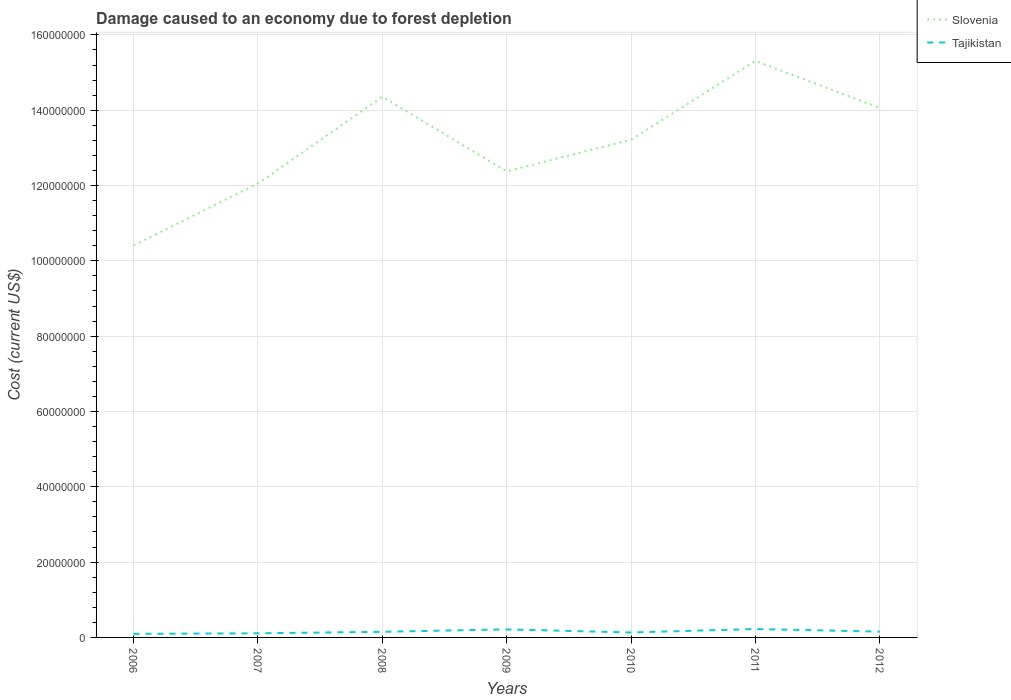How many different coloured lines are there?
Offer a terse response. 2. Does the line corresponding to Slovenia intersect with the line corresponding to Tajikistan?
Keep it short and to the point. No. Is the number of lines equal to the number of legend labels?
Your response must be concise. Yes. Across all years, what is the maximum cost of damage caused due to forest depletion in Slovenia?
Make the answer very short. 1.04e+08. In which year was the cost of damage caused due to forest depletion in Tajikistan maximum?
Keep it short and to the point. 2006. What is the total cost of damage caused due to forest depletion in Slovenia in the graph?
Give a very brief answer. -3.65e+07. What is the difference between the highest and the second highest cost of damage caused due to forest depletion in Tajikistan?
Your response must be concise. 1.28e+06. What is the difference between the highest and the lowest cost of damage caused due to forest depletion in Slovenia?
Offer a terse response. 4. How many years are there in the graph?
Offer a terse response. 7. What is the difference between two consecutive major ticks on the Y-axis?
Ensure brevity in your answer.  2.00e+07. Does the graph contain any zero values?
Offer a very short reply. No. Where does the legend appear in the graph?
Your response must be concise. Top right. How many legend labels are there?
Offer a very short reply. 2. What is the title of the graph?
Your answer should be compact. Damage caused to an economy due to forest depletion. What is the label or title of the Y-axis?
Your response must be concise. Cost (current US$). What is the Cost (current US$) of Slovenia in 2006?
Provide a short and direct response. 1.04e+08. What is the Cost (current US$) in Tajikistan in 2006?
Ensure brevity in your answer.  9.51e+05. What is the Cost (current US$) in Slovenia in 2007?
Offer a very short reply. 1.21e+08. What is the Cost (current US$) in Tajikistan in 2007?
Give a very brief answer. 1.10e+06. What is the Cost (current US$) in Slovenia in 2008?
Provide a succinct answer. 1.44e+08. What is the Cost (current US$) of Tajikistan in 2008?
Give a very brief answer. 1.50e+06. What is the Cost (current US$) in Slovenia in 2009?
Keep it short and to the point. 1.24e+08. What is the Cost (current US$) of Tajikistan in 2009?
Your answer should be very brief. 2.13e+06. What is the Cost (current US$) of Slovenia in 2010?
Ensure brevity in your answer.  1.32e+08. What is the Cost (current US$) of Tajikistan in 2010?
Your answer should be very brief. 1.31e+06. What is the Cost (current US$) of Slovenia in 2011?
Your response must be concise. 1.53e+08. What is the Cost (current US$) in Tajikistan in 2011?
Offer a very short reply. 2.23e+06. What is the Cost (current US$) in Slovenia in 2012?
Your response must be concise. 1.41e+08. What is the Cost (current US$) of Tajikistan in 2012?
Offer a terse response. 1.55e+06. Across all years, what is the maximum Cost (current US$) of Slovenia?
Ensure brevity in your answer.  1.53e+08. Across all years, what is the maximum Cost (current US$) of Tajikistan?
Ensure brevity in your answer.  2.23e+06. Across all years, what is the minimum Cost (current US$) of Slovenia?
Your answer should be compact. 1.04e+08. Across all years, what is the minimum Cost (current US$) in Tajikistan?
Your response must be concise. 9.51e+05. What is the total Cost (current US$) of Slovenia in the graph?
Give a very brief answer. 9.18e+08. What is the total Cost (current US$) of Tajikistan in the graph?
Provide a succinct answer. 1.08e+07. What is the difference between the Cost (current US$) in Slovenia in 2006 and that in 2007?
Ensure brevity in your answer.  -1.64e+07. What is the difference between the Cost (current US$) in Tajikistan in 2006 and that in 2007?
Make the answer very short. -1.45e+05. What is the difference between the Cost (current US$) of Slovenia in 2006 and that in 2008?
Ensure brevity in your answer.  -3.95e+07. What is the difference between the Cost (current US$) in Tajikistan in 2006 and that in 2008?
Your answer should be compact. -5.46e+05. What is the difference between the Cost (current US$) in Slovenia in 2006 and that in 2009?
Provide a short and direct response. -1.97e+07. What is the difference between the Cost (current US$) of Tajikistan in 2006 and that in 2009?
Give a very brief answer. -1.18e+06. What is the difference between the Cost (current US$) in Slovenia in 2006 and that in 2010?
Your answer should be very brief. -2.81e+07. What is the difference between the Cost (current US$) in Tajikistan in 2006 and that in 2010?
Keep it short and to the point. -3.62e+05. What is the difference between the Cost (current US$) in Slovenia in 2006 and that in 2011?
Offer a terse response. -4.90e+07. What is the difference between the Cost (current US$) of Tajikistan in 2006 and that in 2011?
Provide a succinct answer. -1.28e+06. What is the difference between the Cost (current US$) of Slovenia in 2006 and that in 2012?
Give a very brief answer. -3.65e+07. What is the difference between the Cost (current US$) in Tajikistan in 2006 and that in 2012?
Provide a short and direct response. -5.98e+05. What is the difference between the Cost (current US$) of Slovenia in 2007 and that in 2008?
Your response must be concise. -2.31e+07. What is the difference between the Cost (current US$) in Tajikistan in 2007 and that in 2008?
Keep it short and to the point. -4.01e+05. What is the difference between the Cost (current US$) in Slovenia in 2007 and that in 2009?
Offer a very short reply. -3.25e+06. What is the difference between the Cost (current US$) of Tajikistan in 2007 and that in 2009?
Offer a very short reply. -1.04e+06. What is the difference between the Cost (current US$) in Slovenia in 2007 and that in 2010?
Ensure brevity in your answer.  -1.17e+07. What is the difference between the Cost (current US$) in Tajikistan in 2007 and that in 2010?
Your answer should be very brief. -2.16e+05. What is the difference between the Cost (current US$) of Slovenia in 2007 and that in 2011?
Offer a terse response. -3.26e+07. What is the difference between the Cost (current US$) in Tajikistan in 2007 and that in 2011?
Provide a succinct answer. -1.13e+06. What is the difference between the Cost (current US$) in Slovenia in 2007 and that in 2012?
Provide a succinct answer. -2.01e+07. What is the difference between the Cost (current US$) of Tajikistan in 2007 and that in 2012?
Give a very brief answer. -4.52e+05. What is the difference between the Cost (current US$) in Slovenia in 2008 and that in 2009?
Provide a succinct answer. 1.98e+07. What is the difference between the Cost (current US$) in Tajikistan in 2008 and that in 2009?
Make the answer very short. -6.36e+05. What is the difference between the Cost (current US$) of Slovenia in 2008 and that in 2010?
Provide a short and direct response. 1.14e+07. What is the difference between the Cost (current US$) in Tajikistan in 2008 and that in 2010?
Offer a very short reply. 1.84e+05. What is the difference between the Cost (current US$) of Slovenia in 2008 and that in 2011?
Provide a succinct answer. -9.53e+06. What is the difference between the Cost (current US$) of Tajikistan in 2008 and that in 2011?
Your response must be concise. -7.31e+05. What is the difference between the Cost (current US$) of Slovenia in 2008 and that in 2012?
Offer a terse response. 2.99e+06. What is the difference between the Cost (current US$) in Tajikistan in 2008 and that in 2012?
Ensure brevity in your answer.  -5.17e+04. What is the difference between the Cost (current US$) of Slovenia in 2009 and that in 2010?
Your answer should be compact. -8.43e+06. What is the difference between the Cost (current US$) in Tajikistan in 2009 and that in 2010?
Offer a terse response. 8.21e+05. What is the difference between the Cost (current US$) in Slovenia in 2009 and that in 2011?
Provide a short and direct response. -2.93e+07. What is the difference between the Cost (current US$) in Tajikistan in 2009 and that in 2011?
Ensure brevity in your answer.  -9.45e+04. What is the difference between the Cost (current US$) of Slovenia in 2009 and that in 2012?
Your answer should be very brief. -1.68e+07. What is the difference between the Cost (current US$) of Tajikistan in 2009 and that in 2012?
Your answer should be compact. 5.85e+05. What is the difference between the Cost (current US$) in Slovenia in 2010 and that in 2011?
Ensure brevity in your answer.  -2.09e+07. What is the difference between the Cost (current US$) of Tajikistan in 2010 and that in 2011?
Ensure brevity in your answer.  -9.15e+05. What is the difference between the Cost (current US$) of Slovenia in 2010 and that in 2012?
Keep it short and to the point. -8.40e+06. What is the difference between the Cost (current US$) of Tajikistan in 2010 and that in 2012?
Provide a succinct answer. -2.36e+05. What is the difference between the Cost (current US$) in Slovenia in 2011 and that in 2012?
Your answer should be very brief. 1.25e+07. What is the difference between the Cost (current US$) in Tajikistan in 2011 and that in 2012?
Your answer should be compact. 6.79e+05. What is the difference between the Cost (current US$) in Slovenia in 2006 and the Cost (current US$) in Tajikistan in 2007?
Give a very brief answer. 1.03e+08. What is the difference between the Cost (current US$) in Slovenia in 2006 and the Cost (current US$) in Tajikistan in 2008?
Ensure brevity in your answer.  1.03e+08. What is the difference between the Cost (current US$) in Slovenia in 2006 and the Cost (current US$) in Tajikistan in 2009?
Your answer should be compact. 1.02e+08. What is the difference between the Cost (current US$) of Slovenia in 2006 and the Cost (current US$) of Tajikistan in 2010?
Make the answer very short. 1.03e+08. What is the difference between the Cost (current US$) of Slovenia in 2006 and the Cost (current US$) of Tajikistan in 2011?
Make the answer very short. 1.02e+08. What is the difference between the Cost (current US$) in Slovenia in 2006 and the Cost (current US$) in Tajikistan in 2012?
Keep it short and to the point. 1.03e+08. What is the difference between the Cost (current US$) of Slovenia in 2007 and the Cost (current US$) of Tajikistan in 2008?
Offer a terse response. 1.19e+08. What is the difference between the Cost (current US$) of Slovenia in 2007 and the Cost (current US$) of Tajikistan in 2009?
Keep it short and to the point. 1.18e+08. What is the difference between the Cost (current US$) in Slovenia in 2007 and the Cost (current US$) in Tajikistan in 2010?
Provide a short and direct response. 1.19e+08. What is the difference between the Cost (current US$) in Slovenia in 2007 and the Cost (current US$) in Tajikistan in 2011?
Make the answer very short. 1.18e+08. What is the difference between the Cost (current US$) in Slovenia in 2007 and the Cost (current US$) in Tajikistan in 2012?
Give a very brief answer. 1.19e+08. What is the difference between the Cost (current US$) of Slovenia in 2008 and the Cost (current US$) of Tajikistan in 2009?
Your answer should be compact. 1.41e+08. What is the difference between the Cost (current US$) of Slovenia in 2008 and the Cost (current US$) of Tajikistan in 2010?
Provide a short and direct response. 1.42e+08. What is the difference between the Cost (current US$) of Slovenia in 2008 and the Cost (current US$) of Tajikistan in 2011?
Your response must be concise. 1.41e+08. What is the difference between the Cost (current US$) of Slovenia in 2008 and the Cost (current US$) of Tajikistan in 2012?
Keep it short and to the point. 1.42e+08. What is the difference between the Cost (current US$) in Slovenia in 2009 and the Cost (current US$) in Tajikistan in 2010?
Give a very brief answer. 1.22e+08. What is the difference between the Cost (current US$) in Slovenia in 2009 and the Cost (current US$) in Tajikistan in 2011?
Ensure brevity in your answer.  1.22e+08. What is the difference between the Cost (current US$) of Slovenia in 2009 and the Cost (current US$) of Tajikistan in 2012?
Provide a short and direct response. 1.22e+08. What is the difference between the Cost (current US$) of Slovenia in 2010 and the Cost (current US$) of Tajikistan in 2011?
Your answer should be very brief. 1.30e+08. What is the difference between the Cost (current US$) in Slovenia in 2010 and the Cost (current US$) in Tajikistan in 2012?
Ensure brevity in your answer.  1.31e+08. What is the difference between the Cost (current US$) in Slovenia in 2011 and the Cost (current US$) in Tajikistan in 2012?
Your response must be concise. 1.52e+08. What is the average Cost (current US$) of Slovenia per year?
Your answer should be very brief. 1.31e+08. What is the average Cost (current US$) of Tajikistan per year?
Offer a terse response. 1.54e+06. In the year 2006, what is the difference between the Cost (current US$) of Slovenia and Cost (current US$) of Tajikistan?
Offer a very short reply. 1.03e+08. In the year 2007, what is the difference between the Cost (current US$) in Slovenia and Cost (current US$) in Tajikistan?
Provide a succinct answer. 1.19e+08. In the year 2008, what is the difference between the Cost (current US$) in Slovenia and Cost (current US$) in Tajikistan?
Your answer should be compact. 1.42e+08. In the year 2009, what is the difference between the Cost (current US$) in Slovenia and Cost (current US$) in Tajikistan?
Your answer should be very brief. 1.22e+08. In the year 2010, what is the difference between the Cost (current US$) of Slovenia and Cost (current US$) of Tajikistan?
Your answer should be very brief. 1.31e+08. In the year 2011, what is the difference between the Cost (current US$) of Slovenia and Cost (current US$) of Tajikistan?
Ensure brevity in your answer.  1.51e+08. In the year 2012, what is the difference between the Cost (current US$) of Slovenia and Cost (current US$) of Tajikistan?
Offer a very short reply. 1.39e+08. What is the ratio of the Cost (current US$) of Slovenia in 2006 to that in 2007?
Offer a terse response. 0.86. What is the ratio of the Cost (current US$) of Tajikistan in 2006 to that in 2007?
Your answer should be compact. 0.87. What is the ratio of the Cost (current US$) in Slovenia in 2006 to that in 2008?
Ensure brevity in your answer.  0.72. What is the ratio of the Cost (current US$) of Tajikistan in 2006 to that in 2008?
Offer a very short reply. 0.64. What is the ratio of the Cost (current US$) in Slovenia in 2006 to that in 2009?
Provide a short and direct response. 0.84. What is the ratio of the Cost (current US$) of Tajikistan in 2006 to that in 2009?
Offer a terse response. 0.45. What is the ratio of the Cost (current US$) in Slovenia in 2006 to that in 2010?
Offer a very short reply. 0.79. What is the ratio of the Cost (current US$) of Tajikistan in 2006 to that in 2010?
Make the answer very short. 0.72. What is the ratio of the Cost (current US$) of Slovenia in 2006 to that in 2011?
Keep it short and to the point. 0.68. What is the ratio of the Cost (current US$) in Tajikistan in 2006 to that in 2011?
Give a very brief answer. 0.43. What is the ratio of the Cost (current US$) in Slovenia in 2006 to that in 2012?
Your answer should be very brief. 0.74. What is the ratio of the Cost (current US$) of Tajikistan in 2006 to that in 2012?
Give a very brief answer. 0.61. What is the ratio of the Cost (current US$) in Slovenia in 2007 to that in 2008?
Provide a succinct answer. 0.84. What is the ratio of the Cost (current US$) of Tajikistan in 2007 to that in 2008?
Offer a terse response. 0.73. What is the ratio of the Cost (current US$) of Slovenia in 2007 to that in 2009?
Provide a short and direct response. 0.97. What is the ratio of the Cost (current US$) of Tajikistan in 2007 to that in 2009?
Your answer should be very brief. 0.51. What is the ratio of the Cost (current US$) of Slovenia in 2007 to that in 2010?
Ensure brevity in your answer.  0.91. What is the ratio of the Cost (current US$) of Tajikistan in 2007 to that in 2010?
Ensure brevity in your answer.  0.84. What is the ratio of the Cost (current US$) of Slovenia in 2007 to that in 2011?
Offer a very short reply. 0.79. What is the ratio of the Cost (current US$) of Tajikistan in 2007 to that in 2011?
Offer a very short reply. 0.49. What is the ratio of the Cost (current US$) in Slovenia in 2007 to that in 2012?
Your response must be concise. 0.86. What is the ratio of the Cost (current US$) of Tajikistan in 2007 to that in 2012?
Ensure brevity in your answer.  0.71. What is the ratio of the Cost (current US$) of Slovenia in 2008 to that in 2009?
Keep it short and to the point. 1.16. What is the ratio of the Cost (current US$) of Tajikistan in 2008 to that in 2009?
Keep it short and to the point. 0.7. What is the ratio of the Cost (current US$) in Slovenia in 2008 to that in 2010?
Provide a succinct answer. 1.09. What is the ratio of the Cost (current US$) of Tajikistan in 2008 to that in 2010?
Your response must be concise. 1.14. What is the ratio of the Cost (current US$) of Slovenia in 2008 to that in 2011?
Offer a terse response. 0.94. What is the ratio of the Cost (current US$) in Tajikistan in 2008 to that in 2011?
Your answer should be compact. 0.67. What is the ratio of the Cost (current US$) in Slovenia in 2008 to that in 2012?
Offer a terse response. 1.02. What is the ratio of the Cost (current US$) of Tajikistan in 2008 to that in 2012?
Your answer should be compact. 0.97. What is the ratio of the Cost (current US$) of Slovenia in 2009 to that in 2010?
Provide a short and direct response. 0.94. What is the ratio of the Cost (current US$) in Tajikistan in 2009 to that in 2010?
Your answer should be compact. 1.62. What is the ratio of the Cost (current US$) in Slovenia in 2009 to that in 2011?
Offer a terse response. 0.81. What is the ratio of the Cost (current US$) in Tajikistan in 2009 to that in 2011?
Offer a terse response. 0.96. What is the ratio of the Cost (current US$) in Slovenia in 2009 to that in 2012?
Keep it short and to the point. 0.88. What is the ratio of the Cost (current US$) of Tajikistan in 2009 to that in 2012?
Provide a short and direct response. 1.38. What is the ratio of the Cost (current US$) in Slovenia in 2010 to that in 2011?
Ensure brevity in your answer.  0.86. What is the ratio of the Cost (current US$) in Tajikistan in 2010 to that in 2011?
Your response must be concise. 0.59. What is the ratio of the Cost (current US$) of Slovenia in 2010 to that in 2012?
Your answer should be compact. 0.94. What is the ratio of the Cost (current US$) in Tajikistan in 2010 to that in 2012?
Provide a succinct answer. 0.85. What is the ratio of the Cost (current US$) of Slovenia in 2011 to that in 2012?
Keep it short and to the point. 1.09. What is the ratio of the Cost (current US$) of Tajikistan in 2011 to that in 2012?
Your answer should be very brief. 1.44. What is the difference between the highest and the second highest Cost (current US$) of Slovenia?
Ensure brevity in your answer.  9.53e+06. What is the difference between the highest and the second highest Cost (current US$) of Tajikistan?
Keep it short and to the point. 9.45e+04. What is the difference between the highest and the lowest Cost (current US$) in Slovenia?
Your answer should be compact. 4.90e+07. What is the difference between the highest and the lowest Cost (current US$) in Tajikistan?
Make the answer very short. 1.28e+06. 